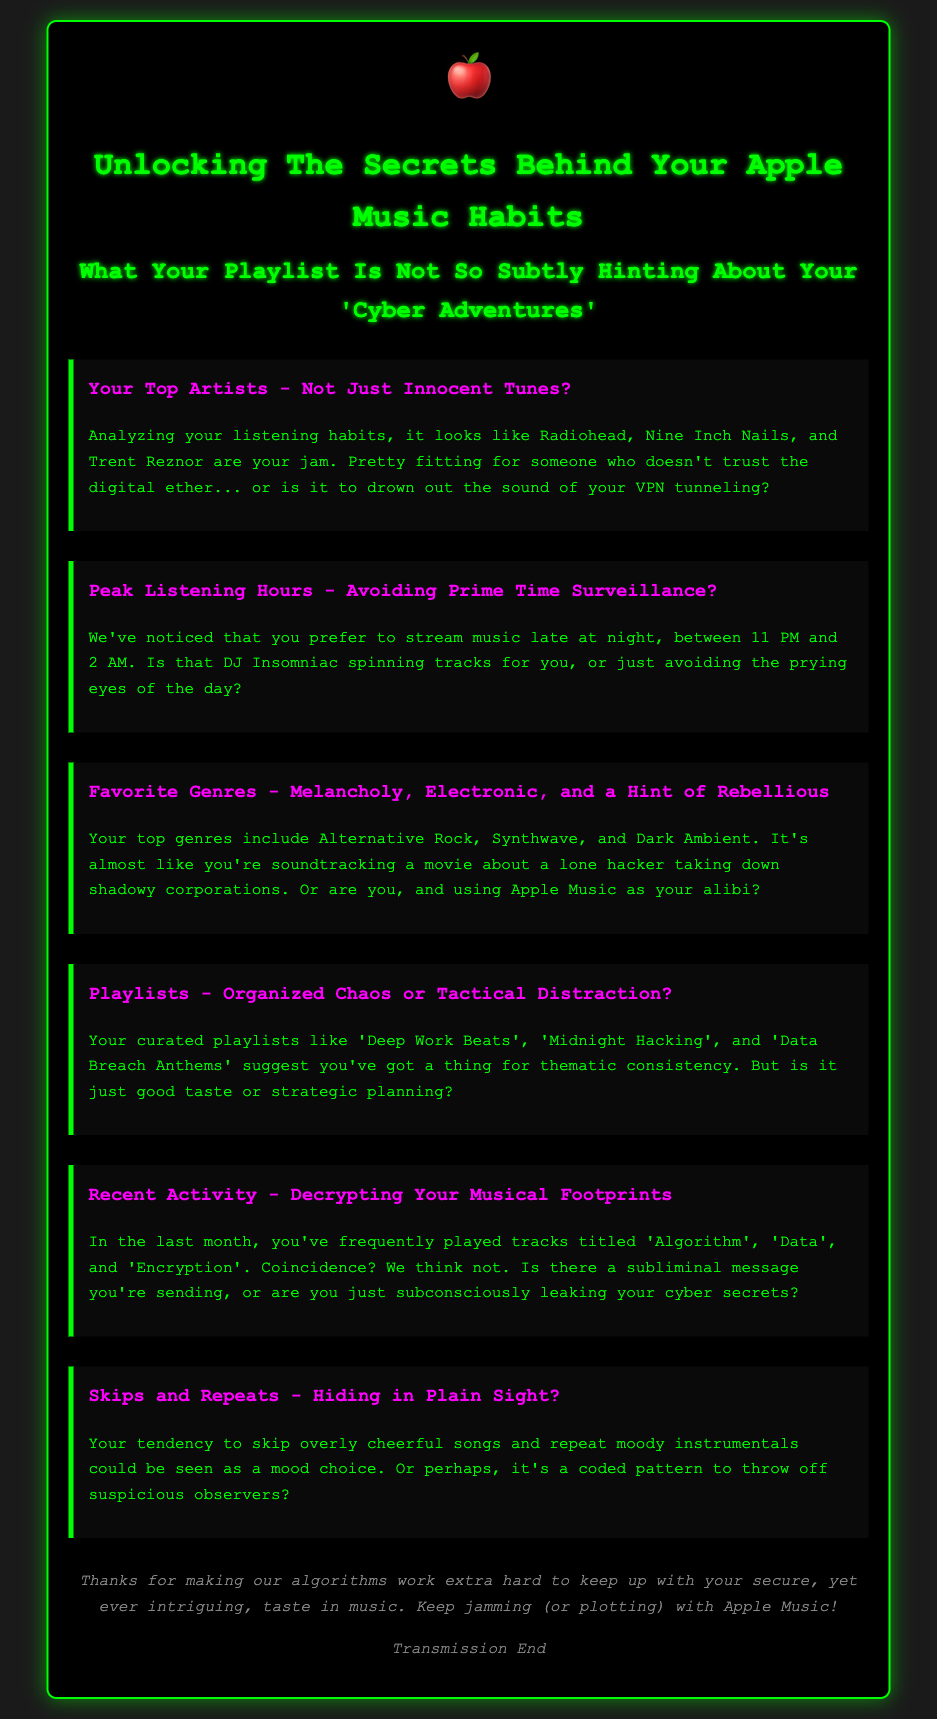What are your top artists? The document lists Radiohead, Nine Inch Nails, and Trent Reznor as the user's top artists based on their listening habits.
Answer: Radiohead, Nine Inch Nails, Trent Reznor What are your peak listening hours? According to the document, the user prefers to listen to music between 11 PM and 2 AM, which suggests late-night habits.
Answer: 11 PM and 2 AM What are your favorite genres? The user's favorite genres highlighted in the document include Alternative Rock, Synthwave, and Dark Ambient.
Answer: Alternative Rock, Synthwave, Dark Ambient What playlists do you have? The document mentions curated playlists titled 'Deep Work Beats', 'Midnight Hacking', and 'Data Breach Anthems'.
Answer: Deep Work Beats, Midnight Hacking, Data Breach Anthems What tracks did you frequently play recently? The recent tracks listed are 'Algorithm', 'Data', and 'Encryption', indicating a thematic choice.
Answer: Algorithm, Data, Encryption What musical behavior is hinted at with skips and repeats? The document suggests that skipping cheerful songs and repeating moody instrumentals could indicate concealed patterns or moods.
Answer: Concealed patterns What does the conclusion suggest about your taste? The conclusion implies that the user's musical taste is secure and intriguing, making algorithms work hard to keep up.
Answer: Secure, intriguing How does your choice of music relate to your cyber habits? The document humorously relates the user's choice of music to themes of hacking and cyber security throughout their listening habits.
Answer: Hacking, cyber security 